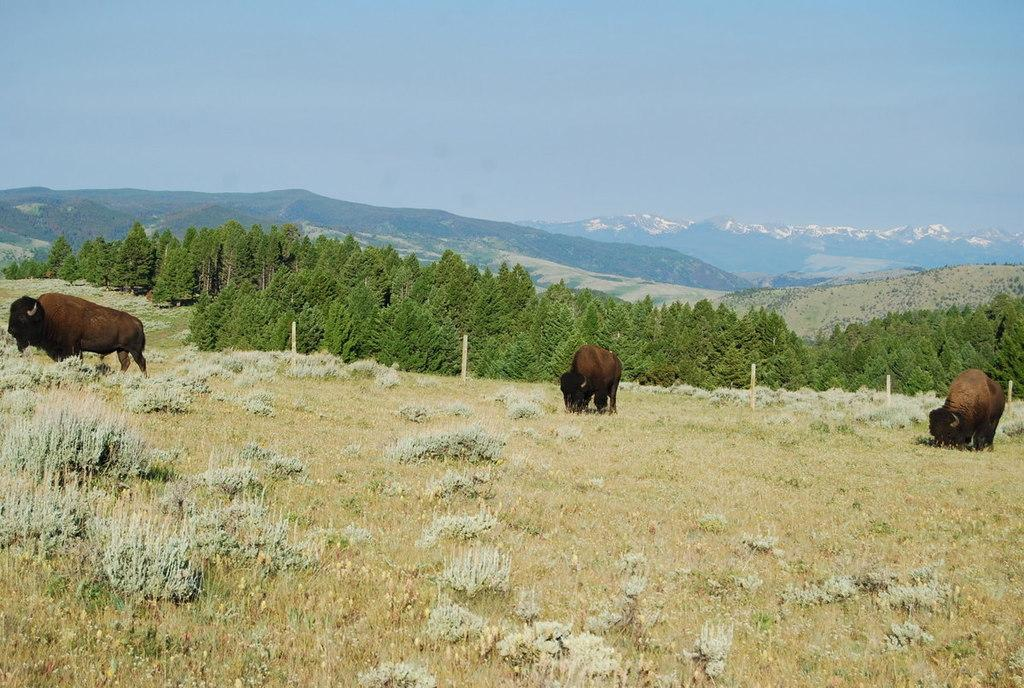How many animals are in the foreground of the image? There are three animals in the foreground of the image. What is the surface the animals are standing on? The animals are on grass. What is located in the foreground of the image besides the animals? There is a fence in the foreground of the image. What can be seen in the background of the image? There are trees, mountains, and the sky visible in the background of the image. Can you determine the time of day the image was taken? The image might have been taken during the day, as the sky is visible and there is no indication of darkness. What type of bead is being used by the minister in the image? There is no minister or bead present in the image. What type of bear can be seen interacting with the animals in the image? There is no bear present in the image; only the three animals are visible. 